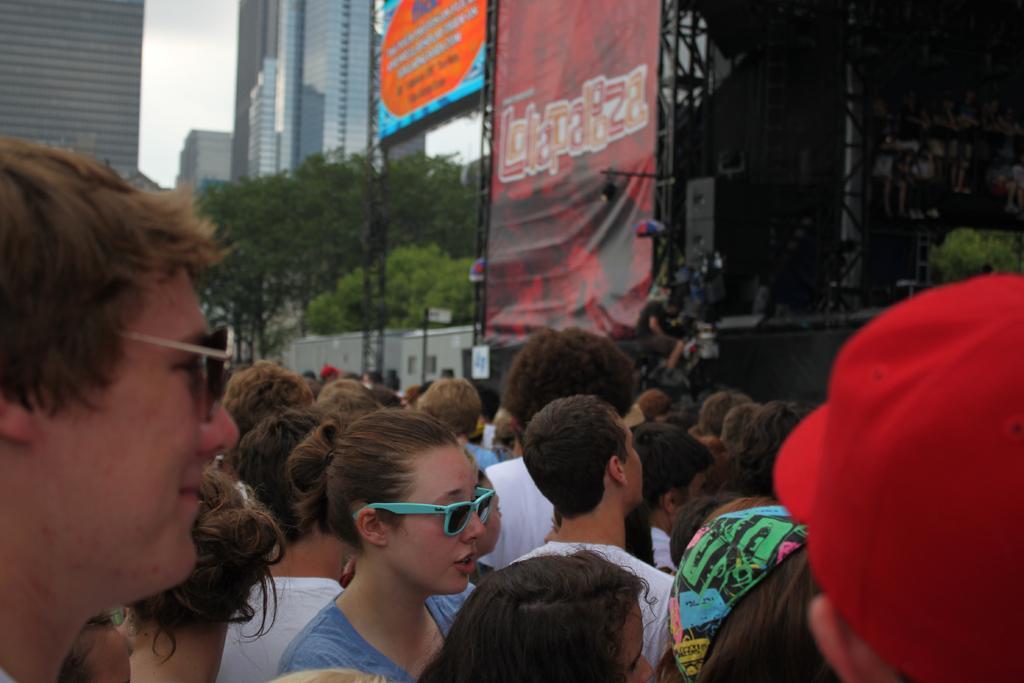Could you give a brief overview of what you see in this image? To the bottom of the image there are many people standing. In the background there are many trees, buildings, rods with posters and also there are speakers. 